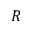<formula> <loc_0><loc_0><loc_500><loc_500>R</formula> 